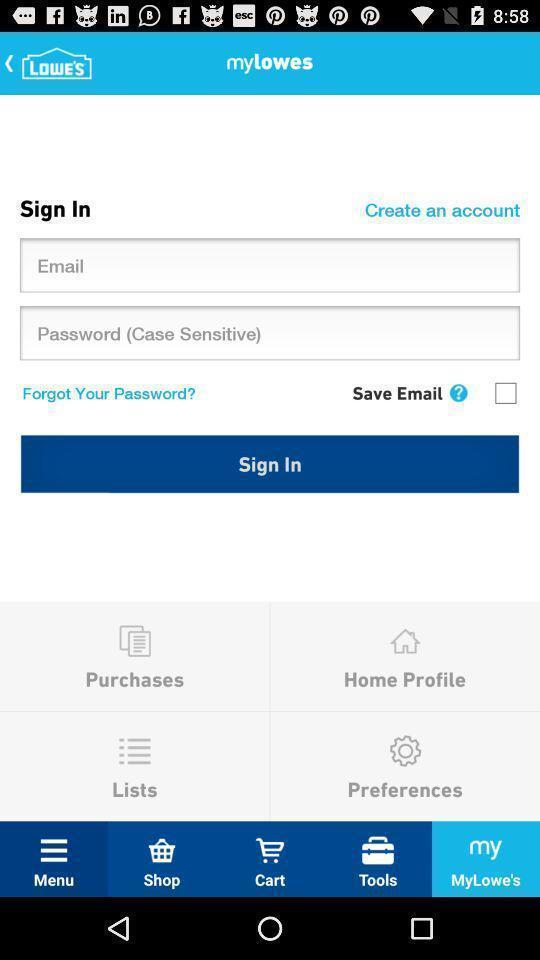Explain what's happening in this screen capture. Sign in page. 